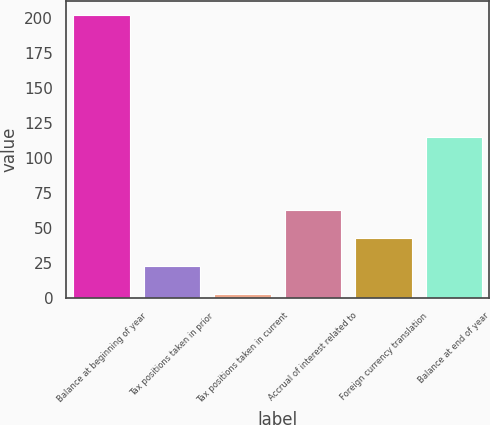Convert chart to OTSL. <chart><loc_0><loc_0><loc_500><loc_500><bar_chart><fcel>Balance at beginning of year<fcel>Tax positions taken in prior<fcel>Tax positions taken in current<fcel>Accrual of interest related to<fcel>Foreign currency translation<fcel>Balance at end of year<nl><fcel>202<fcel>22.9<fcel>3<fcel>62.7<fcel>42.8<fcel>115<nl></chart> 